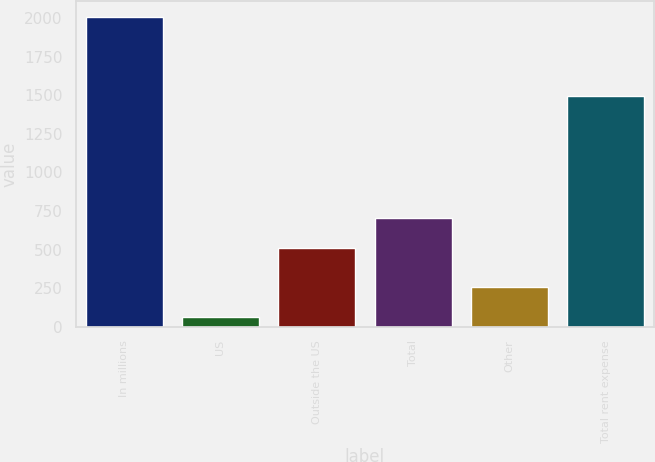Convert chart to OTSL. <chart><loc_0><loc_0><loc_500><loc_500><bar_chart><fcel>In millions<fcel>US<fcel>Outside the US<fcel>Total<fcel>Other<fcel>Total rent expense<nl><fcel>2009<fcel>65.2<fcel>506.9<fcel>701.28<fcel>259.58<fcel>1496.3<nl></chart> 